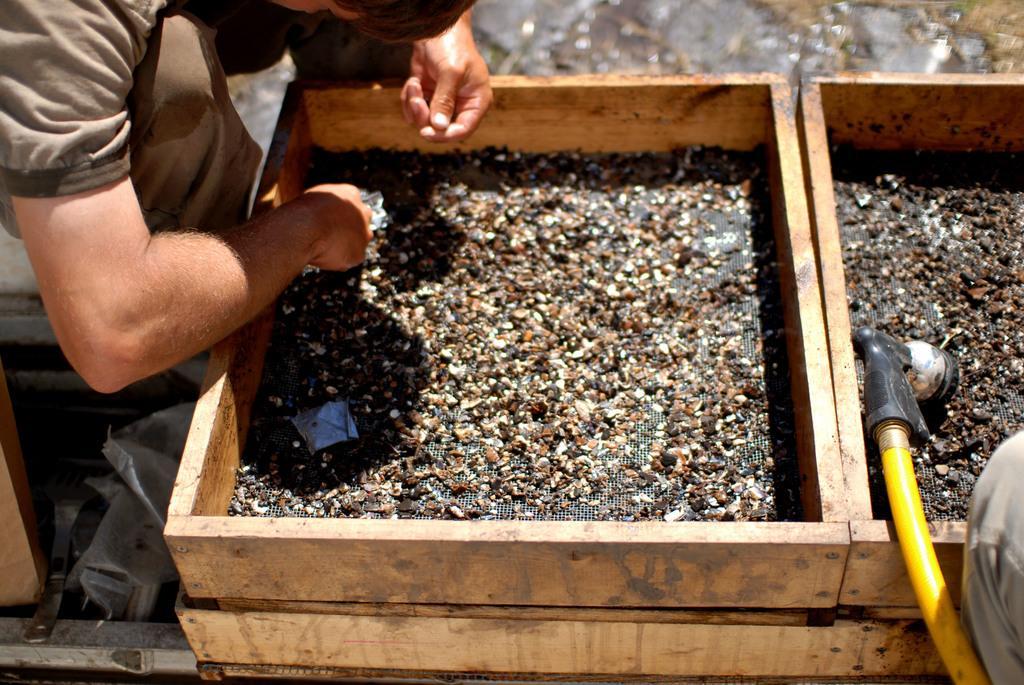How would you summarize this image in a sentence or two? In this image on the left side there is one person who is sitting and he is holding something, and in front of him there are boxes. And in the boxes there is a net, and on the net there are some tiny objects, and there is one pipe and one person legs are visible and also there are some other objects. 